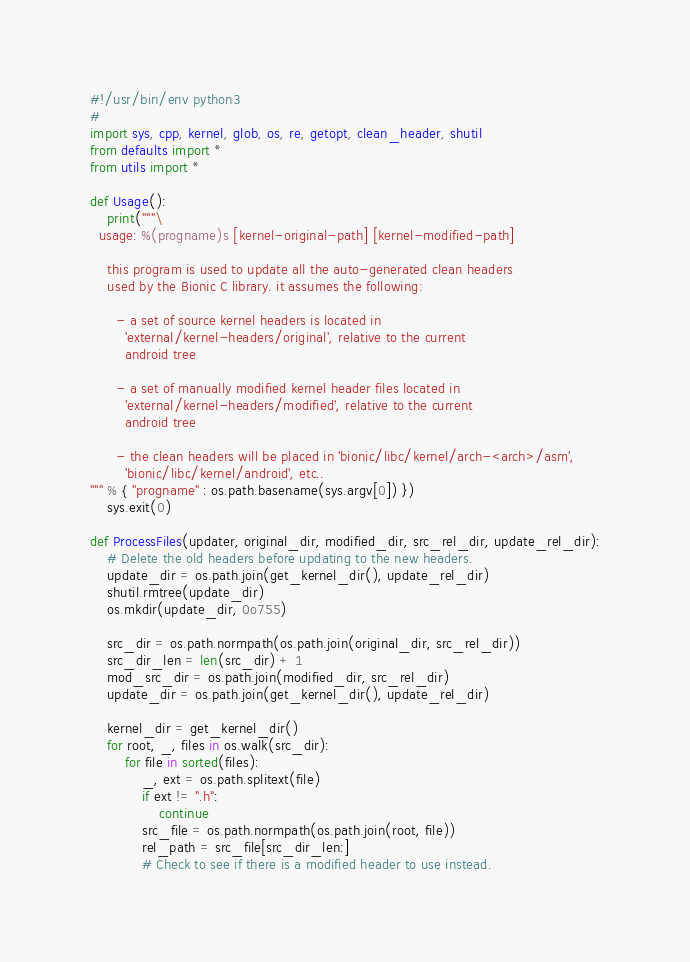<code> <loc_0><loc_0><loc_500><loc_500><_Python_>#!/usr/bin/env python3
#
import sys, cpp, kernel, glob, os, re, getopt, clean_header, shutil
from defaults import *
from utils import *

def Usage():
    print("""\
  usage: %(progname)s [kernel-original-path] [kernel-modified-path]

    this program is used to update all the auto-generated clean headers
    used by the Bionic C library. it assumes the following:

      - a set of source kernel headers is located in
        'external/kernel-headers/original', relative to the current
        android tree

      - a set of manually modified kernel header files located in
        'external/kernel-headers/modified', relative to the current
        android tree

      - the clean headers will be placed in 'bionic/libc/kernel/arch-<arch>/asm',
        'bionic/libc/kernel/android', etc..
""" % { "progname" : os.path.basename(sys.argv[0]) })
    sys.exit(0)

def ProcessFiles(updater, original_dir, modified_dir, src_rel_dir, update_rel_dir):
    # Delete the old headers before updating to the new headers.
    update_dir = os.path.join(get_kernel_dir(), update_rel_dir)
    shutil.rmtree(update_dir)
    os.mkdir(update_dir, 0o755)

    src_dir = os.path.normpath(os.path.join(original_dir, src_rel_dir))
    src_dir_len = len(src_dir) + 1
    mod_src_dir = os.path.join(modified_dir, src_rel_dir)
    update_dir = os.path.join(get_kernel_dir(), update_rel_dir)

    kernel_dir = get_kernel_dir()
    for root, _, files in os.walk(src_dir):
        for file in sorted(files):
            _, ext = os.path.splitext(file)
            if ext != ".h":
                continue
            src_file = os.path.normpath(os.path.join(root, file))
            rel_path = src_file[src_dir_len:]
            # Check to see if there is a modified header to use instead.</code> 